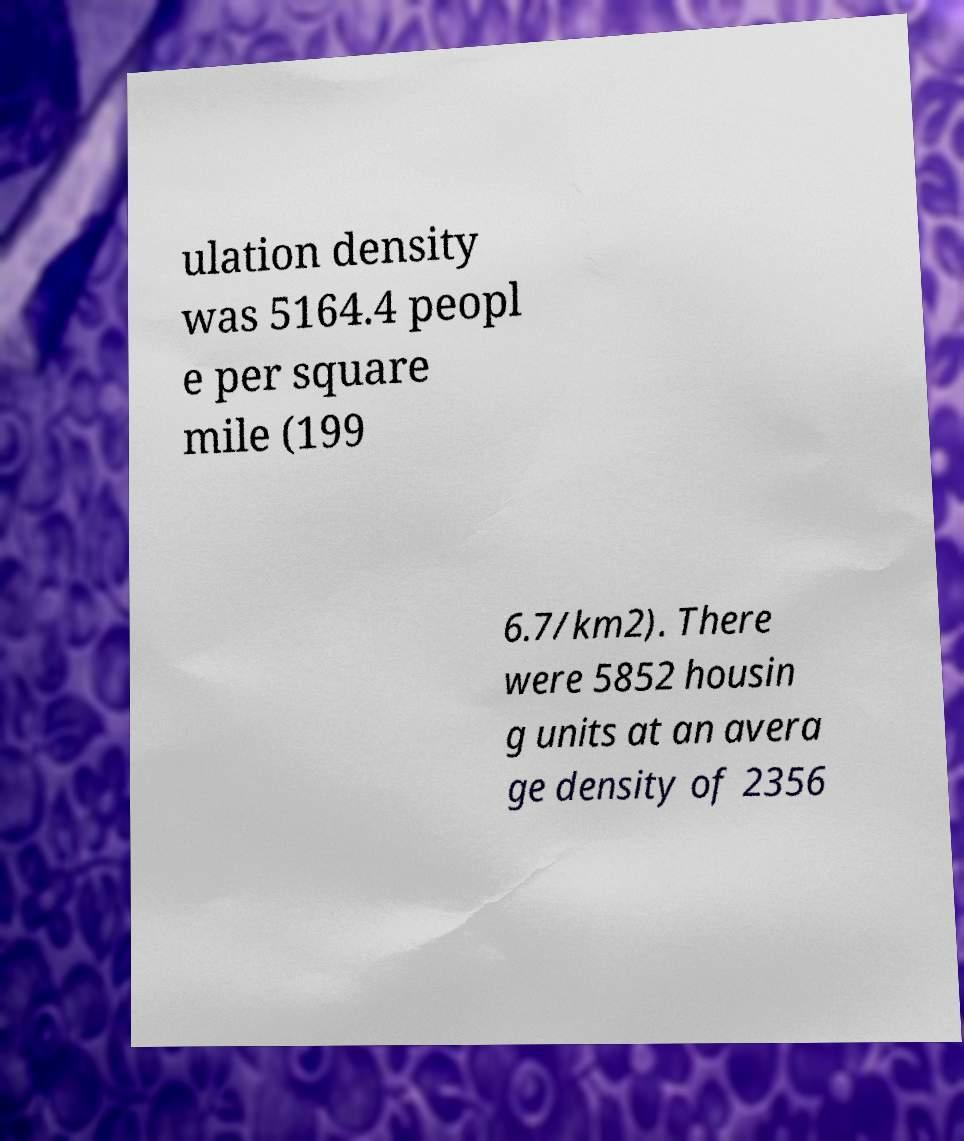For documentation purposes, I need the text within this image transcribed. Could you provide that? ulation density was 5164.4 peopl e per square mile (199 6.7/km2). There were 5852 housin g units at an avera ge density of 2356 